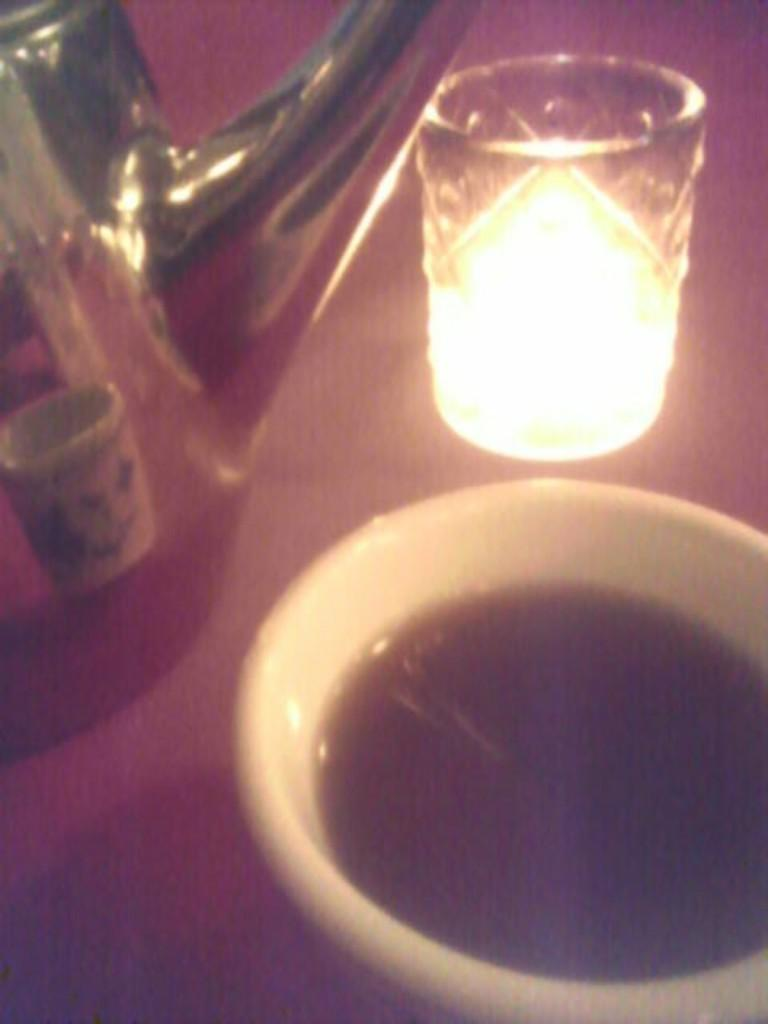What is one of the objects visible in the image? There is a cup in the image. Where is the jar located in the image? The jar is on the left side of the image. What is contained in the glass in the image? There is light in a glass in the image. On what surface are the objects placed? The objects are placed on a surface. How many girls are sitting in the lunchroom in the image? There is no lunchroom or girls present in the image. Are there any mice visible in the image? There are no mice visible in the image. 